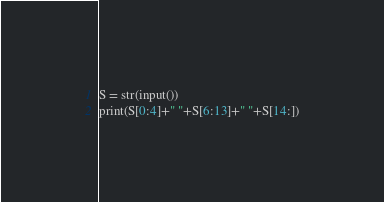<code> <loc_0><loc_0><loc_500><loc_500><_Python_>S = str(input())
print(S[0:4]+" "+S[6:13]+" "+S[14:])
</code> 